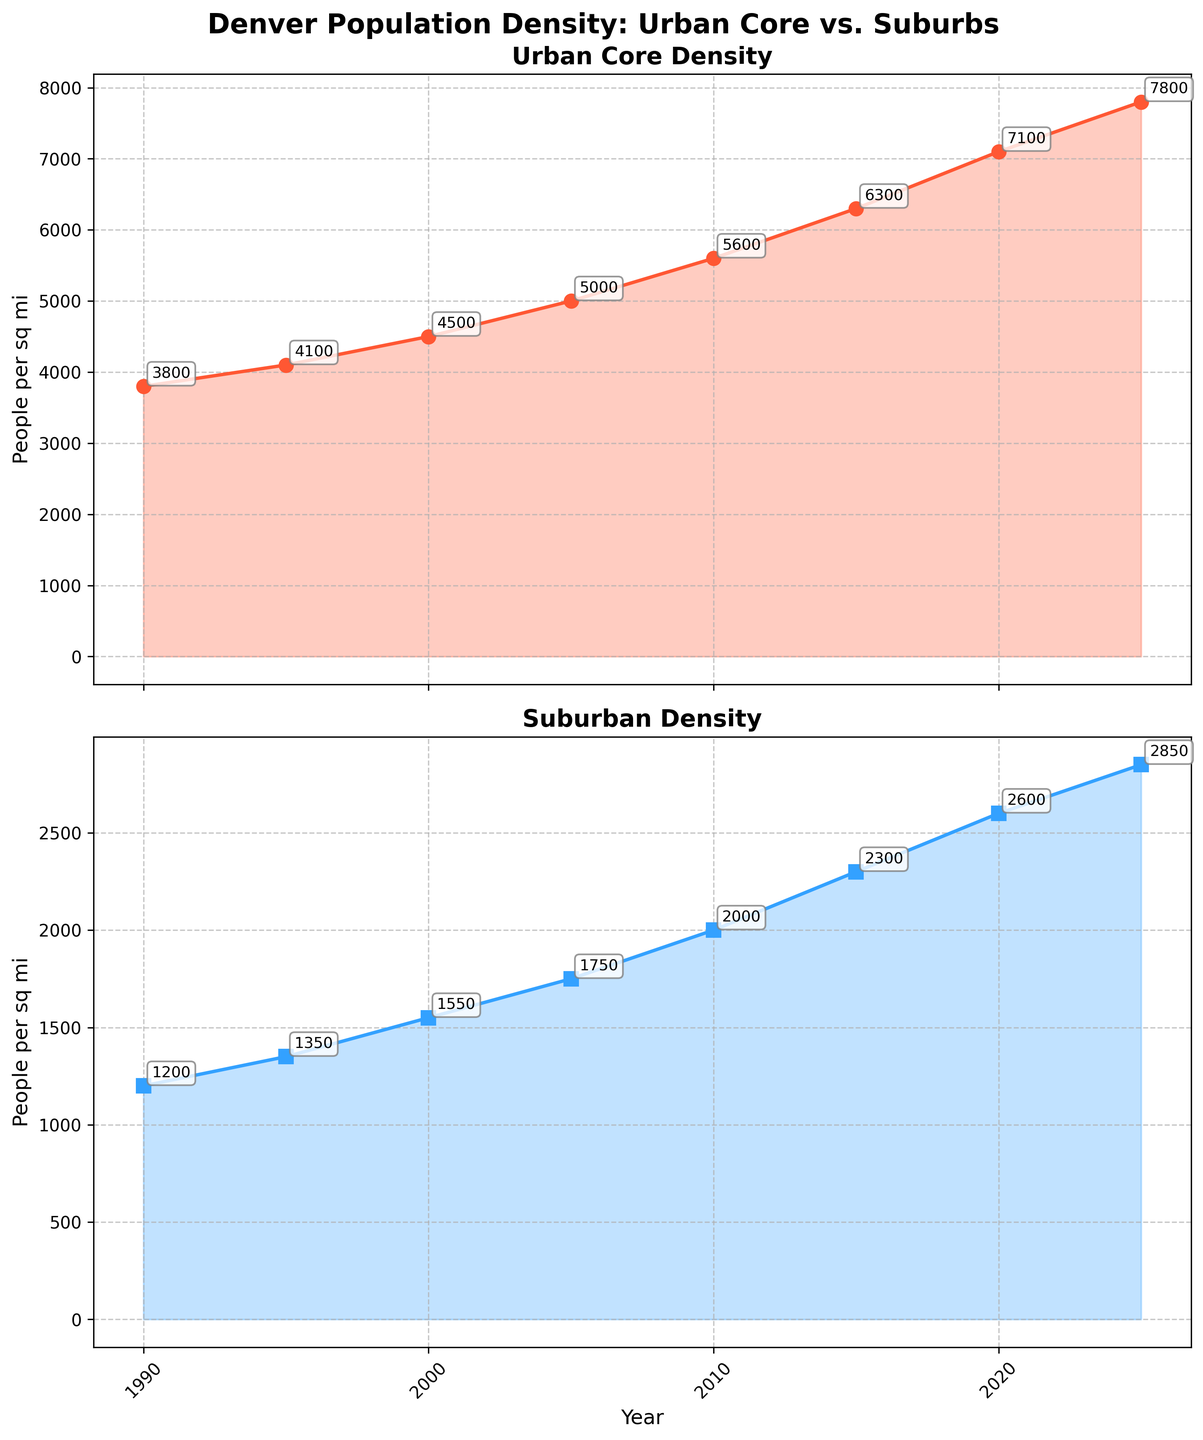What is the title of the plot? The title is displayed at the top of the figure. It reads "Denver Population Density: Urban Core vs. Suburbs"
Answer: Denver Population Density: Urban Core vs. Suburbs What is the highest population density in the Urban Core? The Urban Core subplot shows the density for each year with annotations. The highest value is at the end of the timeline (2025) with a density of 7800 people per square mile.
Answer: 7800 people/sq mi In which year did the Suburban Density first exceed 2000 people/sq mi? By examining the Suburban Density subplot, we see that in the year 2010, the density is marked at 2000. The following value (2015) exceeds 2000.
Answer: 2015 What is the difference in Urban Core Density between 1990 and 2025? The Urban Core density in 1990 is 3800, and in 2025 it is 7800. The difference is calculated as 7800 - 3800 = 4000.
Answer: 4000 How does the growth trend compare between the Urban Core and Suburbs from 1990 to 2025? The Urban Core subplot shows a more rapid increase in population density, from 3800 to 7800. The Suburbs increase from 1200 to 2850, showing a more gradual growth. The growth in the Urban Core is much steeper compared to the suburbs.
Answer: Urban Core grows more rapidly than the suburbs Which subplot is used for showing the density of the Urban Core? The plot title and annotations indicate the Urban Core density is shown in the top subplot.
Answer: The top subplot Between which years is the largest increase in Urban Core Density observed? By looking at the annotations in the Urban Core subplot, the largest increase occurs between 2015 and 2020, from 6300 to 7100. The increase is 7100 - 6300 = 800.
Answer: 2015 to 2020 What is the average population density for the Suburbs from the data provided? Sum all the density values for the Suburbs: 1200 + 1350 + 1550 + 1750 + 2000 + 2300 + 2600 + 2850 = 14600. Divide by the number of years (8) to get the average: 14600 / 8 = 1825.
Answer: 1825 people/sq mi Is the overall trend in population density increasing for both the Urban Core and Suburbs? Both subplots show a consistent upward trend, indicating increasing population densities over the years for both the Urban Core and Suburbs.
Answer: Yes, increasing What are the colors used to differentiate the Urban Core and Suburban data? The Urban Core data is represented with an orange line and markers, while the Suburban data is shown with a blue line and square markers.
Answer: Orange for Urban Core, Blue for Suburbs 